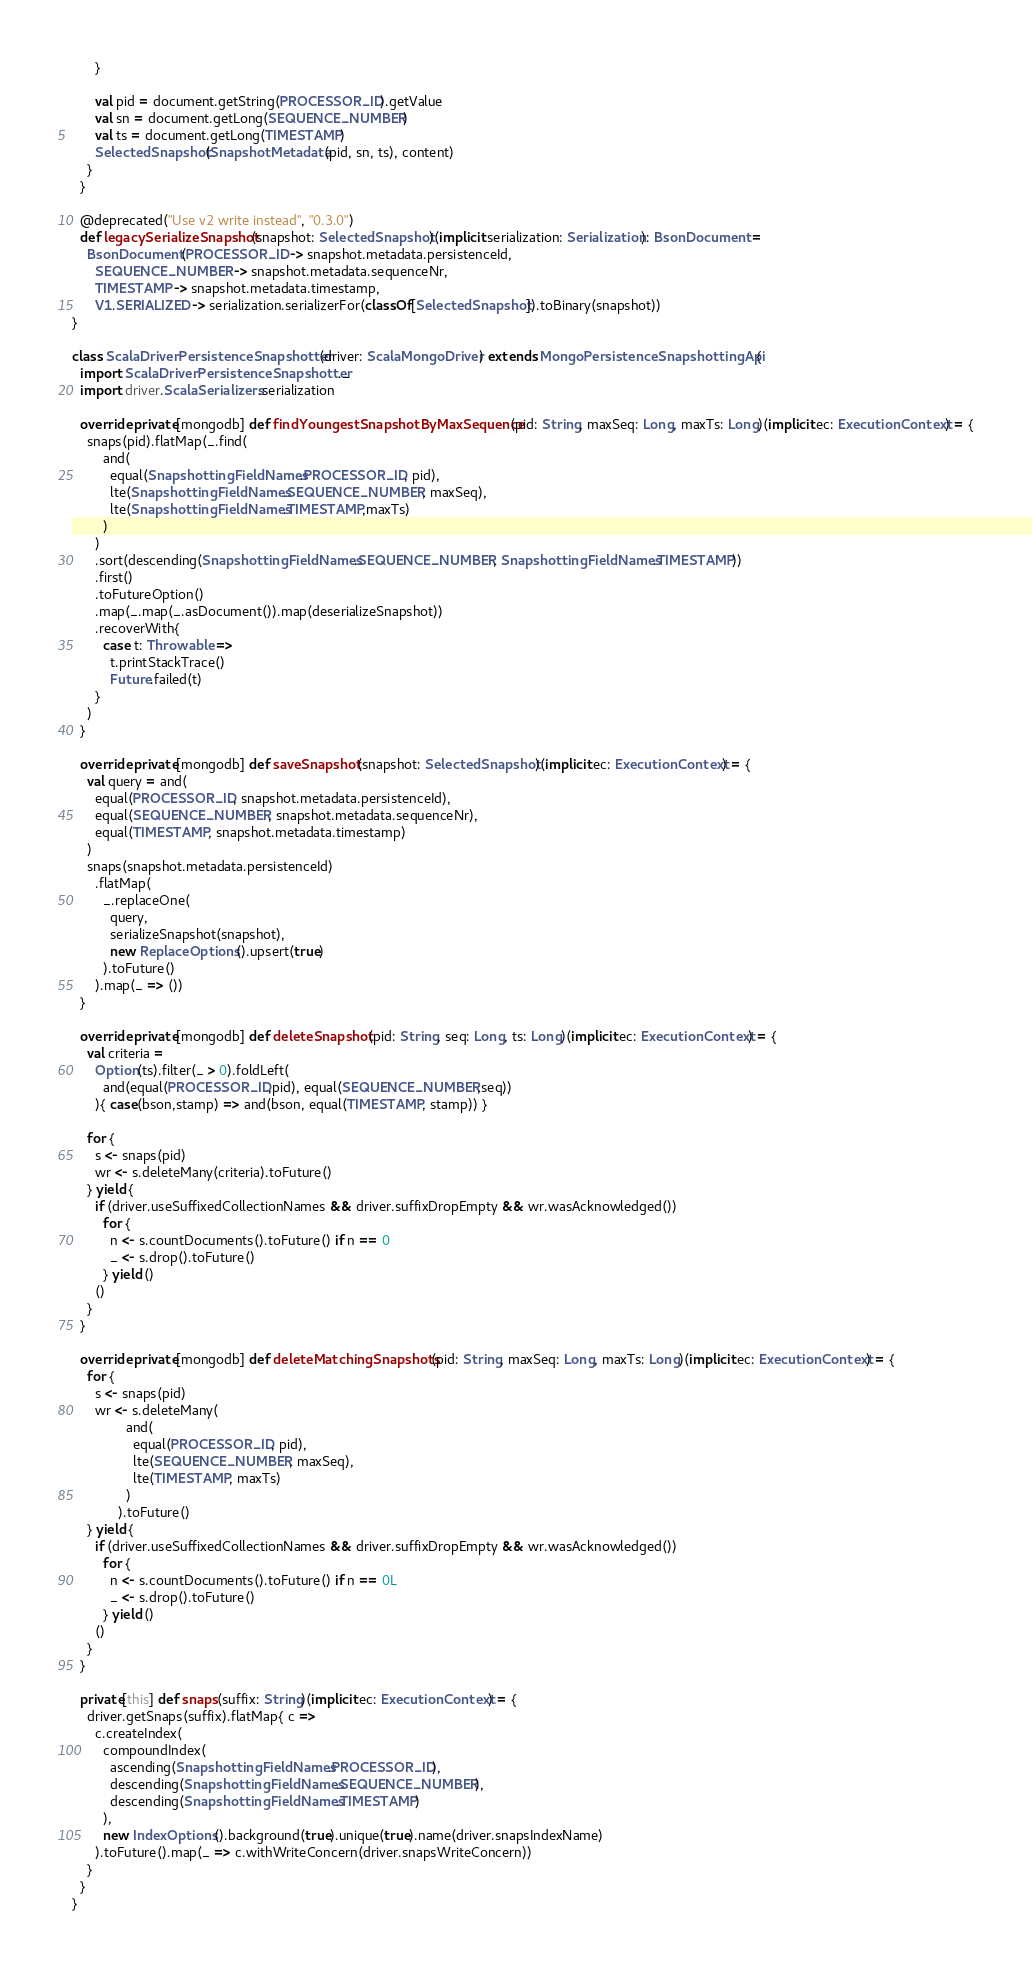Convert code to text. <code><loc_0><loc_0><loc_500><loc_500><_Scala_>      }

      val pid = document.getString(PROCESSOR_ID).getValue
      val sn = document.getLong(SEQUENCE_NUMBER)
      val ts = document.getLong(TIMESTAMP)
      SelectedSnapshot(SnapshotMetadata(pid, sn, ts), content)
    }
  }

  @deprecated("Use v2 write instead", "0.3.0")
  def legacySerializeSnapshot(snapshot: SelectedSnapshot)(implicit serialization: Serialization): BsonDocument =
    BsonDocument(PROCESSOR_ID -> snapshot.metadata.persistenceId,
      SEQUENCE_NUMBER -> snapshot.metadata.sequenceNr,
      TIMESTAMP -> snapshot.metadata.timestamp,
      V1.SERIALIZED -> serialization.serializerFor(classOf[SelectedSnapshot]).toBinary(snapshot))
}

class ScalaDriverPersistenceSnapshotter(driver: ScalaMongoDriver) extends MongoPersistenceSnapshottingApi {
  import ScalaDriverPersistenceSnapshotter._
  import driver.ScalaSerializers.serialization

  override private[mongodb] def findYoungestSnapshotByMaxSequence(pid: String, maxSeq: Long, maxTs: Long)(implicit ec: ExecutionContext) = {
    snaps(pid).flatMap(_.find(
        and(
          equal(SnapshottingFieldNames.PROCESSOR_ID, pid),
          lte(SnapshottingFieldNames.SEQUENCE_NUMBER, maxSeq),
          lte(SnapshottingFieldNames.TIMESTAMP,maxTs)
        )
      )
      .sort(descending(SnapshottingFieldNames.SEQUENCE_NUMBER, SnapshottingFieldNames.TIMESTAMP))
      .first()
      .toFutureOption()
      .map(_.map(_.asDocument()).map(deserializeSnapshot))
      .recoverWith{
        case t: Throwable =>
          t.printStackTrace()
          Future.failed(t)
      }
    )
  }

  override private[mongodb] def saveSnapshot(snapshot: SelectedSnapshot)(implicit ec: ExecutionContext) = {
    val query = and(
      equal(PROCESSOR_ID, snapshot.metadata.persistenceId),
      equal(SEQUENCE_NUMBER, snapshot.metadata.sequenceNr),
      equal(TIMESTAMP, snapshot.metadata.timestamp)
    )
    snaps(snapshot.metadata.persistenceId)
      .flatMap(
        _.replaceOne(
          query,
          serializeSnapshot(snapshot),
          new ReplaceOptions().upsert(true)
        ).toFuture()
      ).map(_ => ())
  }

  override private[mongodb] def deleteSnapshot(pid: String, seq: Long, ts: Long)(implicit ec: ExecutionContext) = {
    val criteria =
      Option(ts).filter(_ > 0).foldLeft(
        and(equal(PROCESSOR_ID,pid), equal(SEQUENCE_NUMBER,seq))
      ){ case(bson,stamp) => and(bson, equal(TIMESTAMP, stamp)) }

    for {
      s <- snaps(pid)
      wr <- s.deleteMany(criteria).toFuture()
    } yield {
      if (driver.useSuffixedCollectionNames && driver.suffixDropEmpty && wr.wasAcknowledged())
        for {
          n <- s.countDocuments().toFuture() if n == 0
          _ <- s.drop().toFuture()
        } yield ()
      ()
    }
  }

  override private[mongodb] def deleteMatchingSnapshots(pid: String, maxSeq: Long, maxTs: Long)(implicit ec: ExecutionContext) = {
    for {
      s <- snaps(pid)
      wr <- s.deleteMany(
              and(
                equal(PROCESSOR_ID, pid),
                lte(SEQUENCE_NUMBER, maxSeq),
                lte(TIMESTAMP, maxTs)
              )
            ).toFuture()
    } yield {
      if (driver.useSuffixedCollectionNames && driver.suffixDropEmpty && wr.wasAcknowledged())
        for {
          n <- s.countDocuments().toFuture() if n == 0L
          _ <- s.drop().toFuture()
        } yield ()
      ()
    }
  }

  private[this] def snaps(suffix: String)(implicit ec: ExecutionContext) = {
    driver.getSnaps(suffix).flatMap{ c =>
      c.createIndex(
        compoundIndex(
          ascending(SnapshottingFieldNames.PROCESSOR_ID),
          descending(SnapshottingFieldNames.SEQUENCE_NUMBER),
          descending(SnapshottingFieldNames.TIMESTAMP)
        ),
        new IndexOptions().background(true).unique(true).name(driver.snapsIndexName)
      ).toFuture().map(_ => c.withWriteConcern(driver.snapsWriteConcern))
    }
  }
}
</code> 